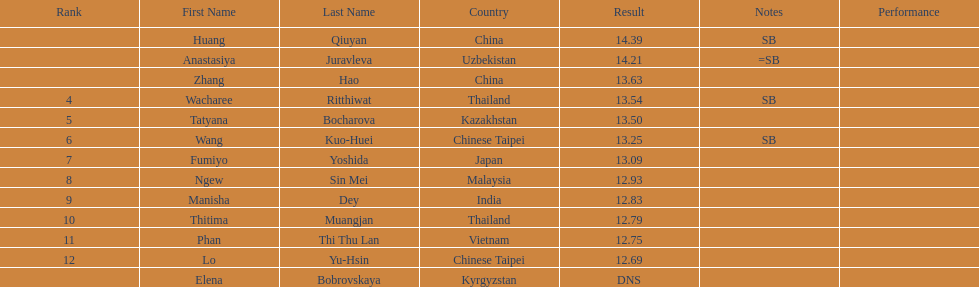How many points apart were the 1st place competitor and the 12th place competitor? 1.7. 